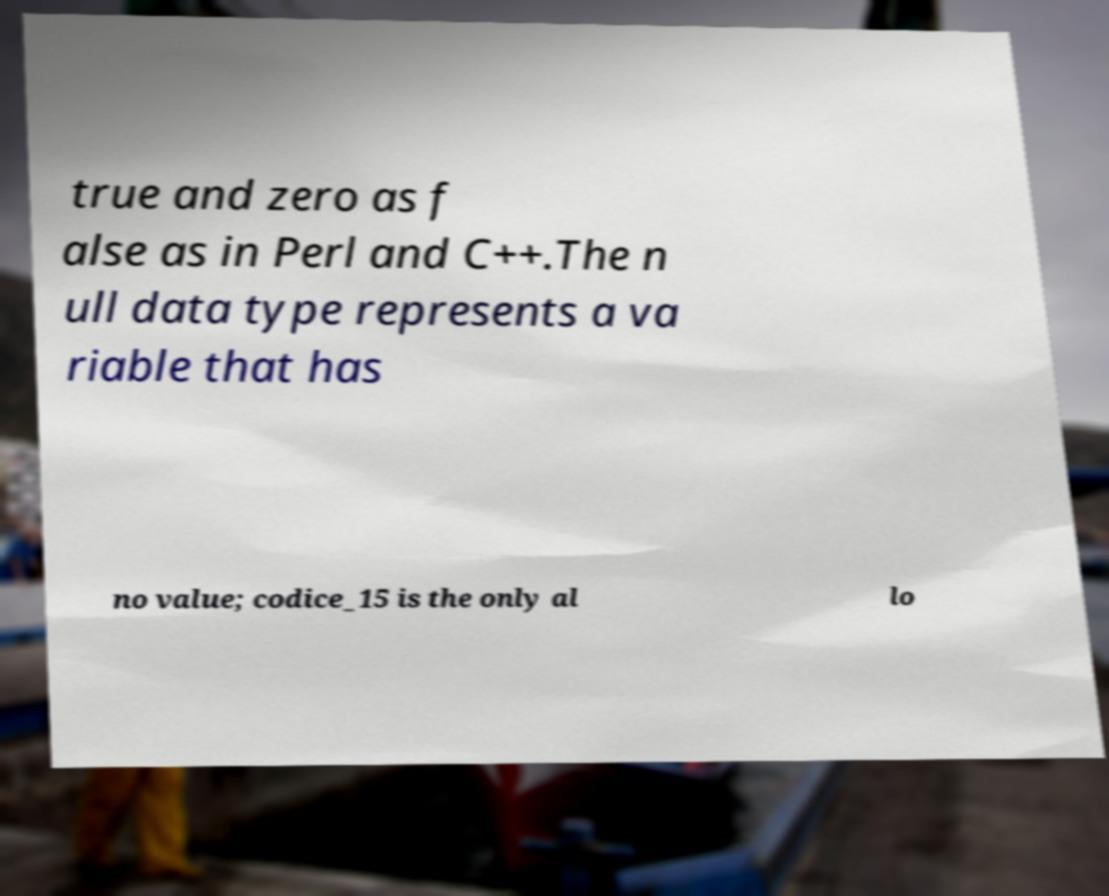Could you extract and type out the text from this image? true and zero as f alse as in Perl and C++.The n ull data type represents a va riable that has no value; codice_15 is the only al lo 